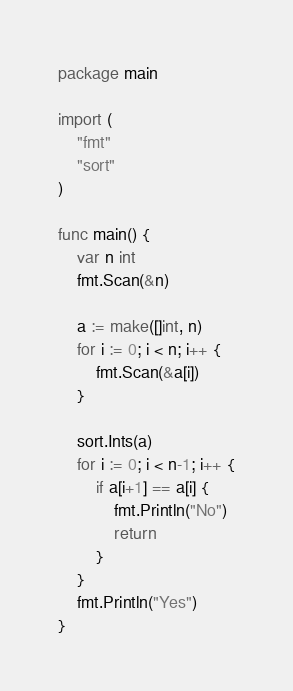Convert code to text. <code><loc_0><loc_0><loc_500><loc_500><_Go_>package main

import (
	"fmt"
	"sort"
)

func main() {
	var n int
	fmt.Scan(&n)

	a := make([]int, n)
	for i := 0; i < n; i++ {
		fmt.Scan(&a[i])
	}

	sort.Ints(a)
	for i := 0; i < n-1; i++ {
		if a[i+1] == a[i] {
			fmt.Println("No")
			return
		}
	}
	fmt.Println("Yes")
}
</code> 